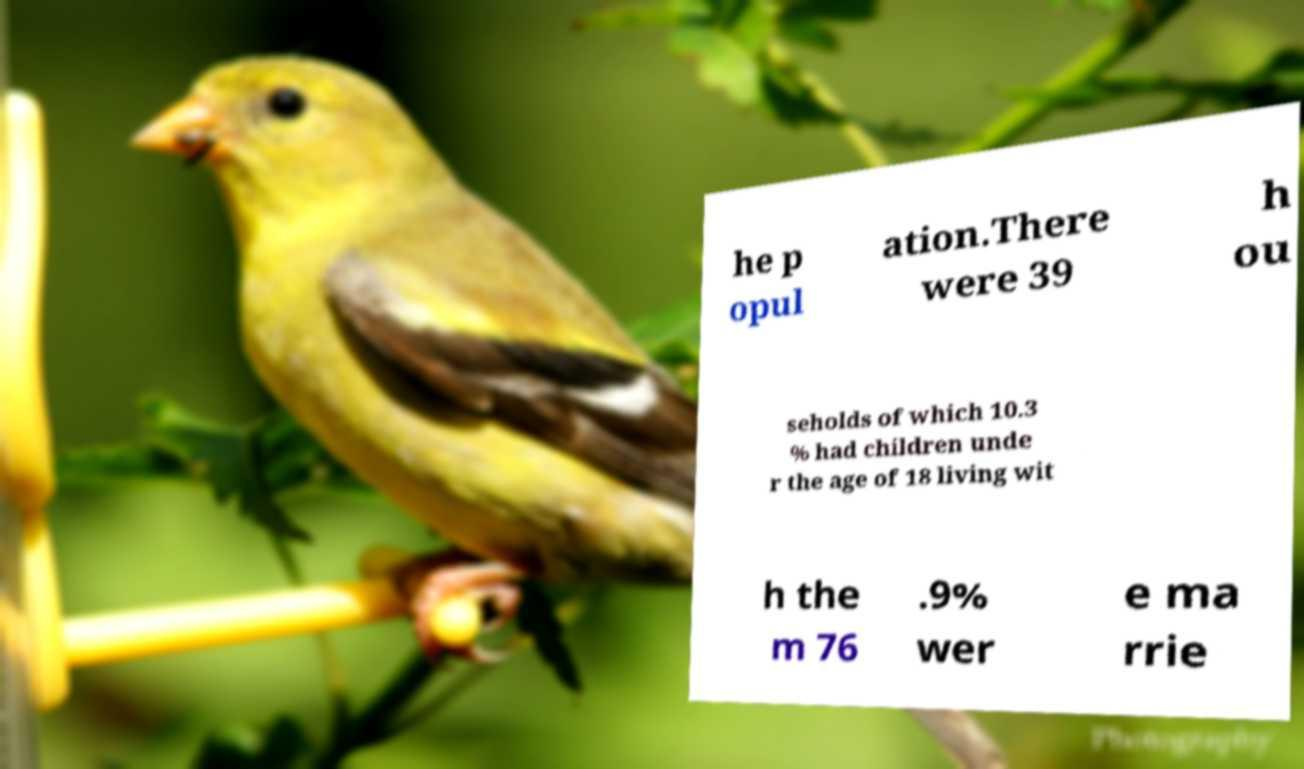Can you read and provide the text displayed in the image?This photo seems to have some interesting text. Can you extract and type it out for me? he p opul ation.There were 39 h ou seholds of which 10.3 % had children unde r the age of 18 living wit h the m 76 .9% wer e ma rrie 